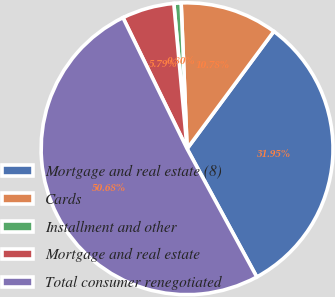Convert chart to OTSL. <chart><loc_0><loc_0><loc_500><loc_500><pie_chart><fcel>Mortgage and real estate (8)<fcel>Cards<fcel>Installment and other<fcel>Mortgage and real estate<fcel>Total consumer renegotiated<nl><fcel>31.95%<fcel>10.78%<fcel>0.8%<fcel>5.79%<fcel>50.69%<nl></chart> 